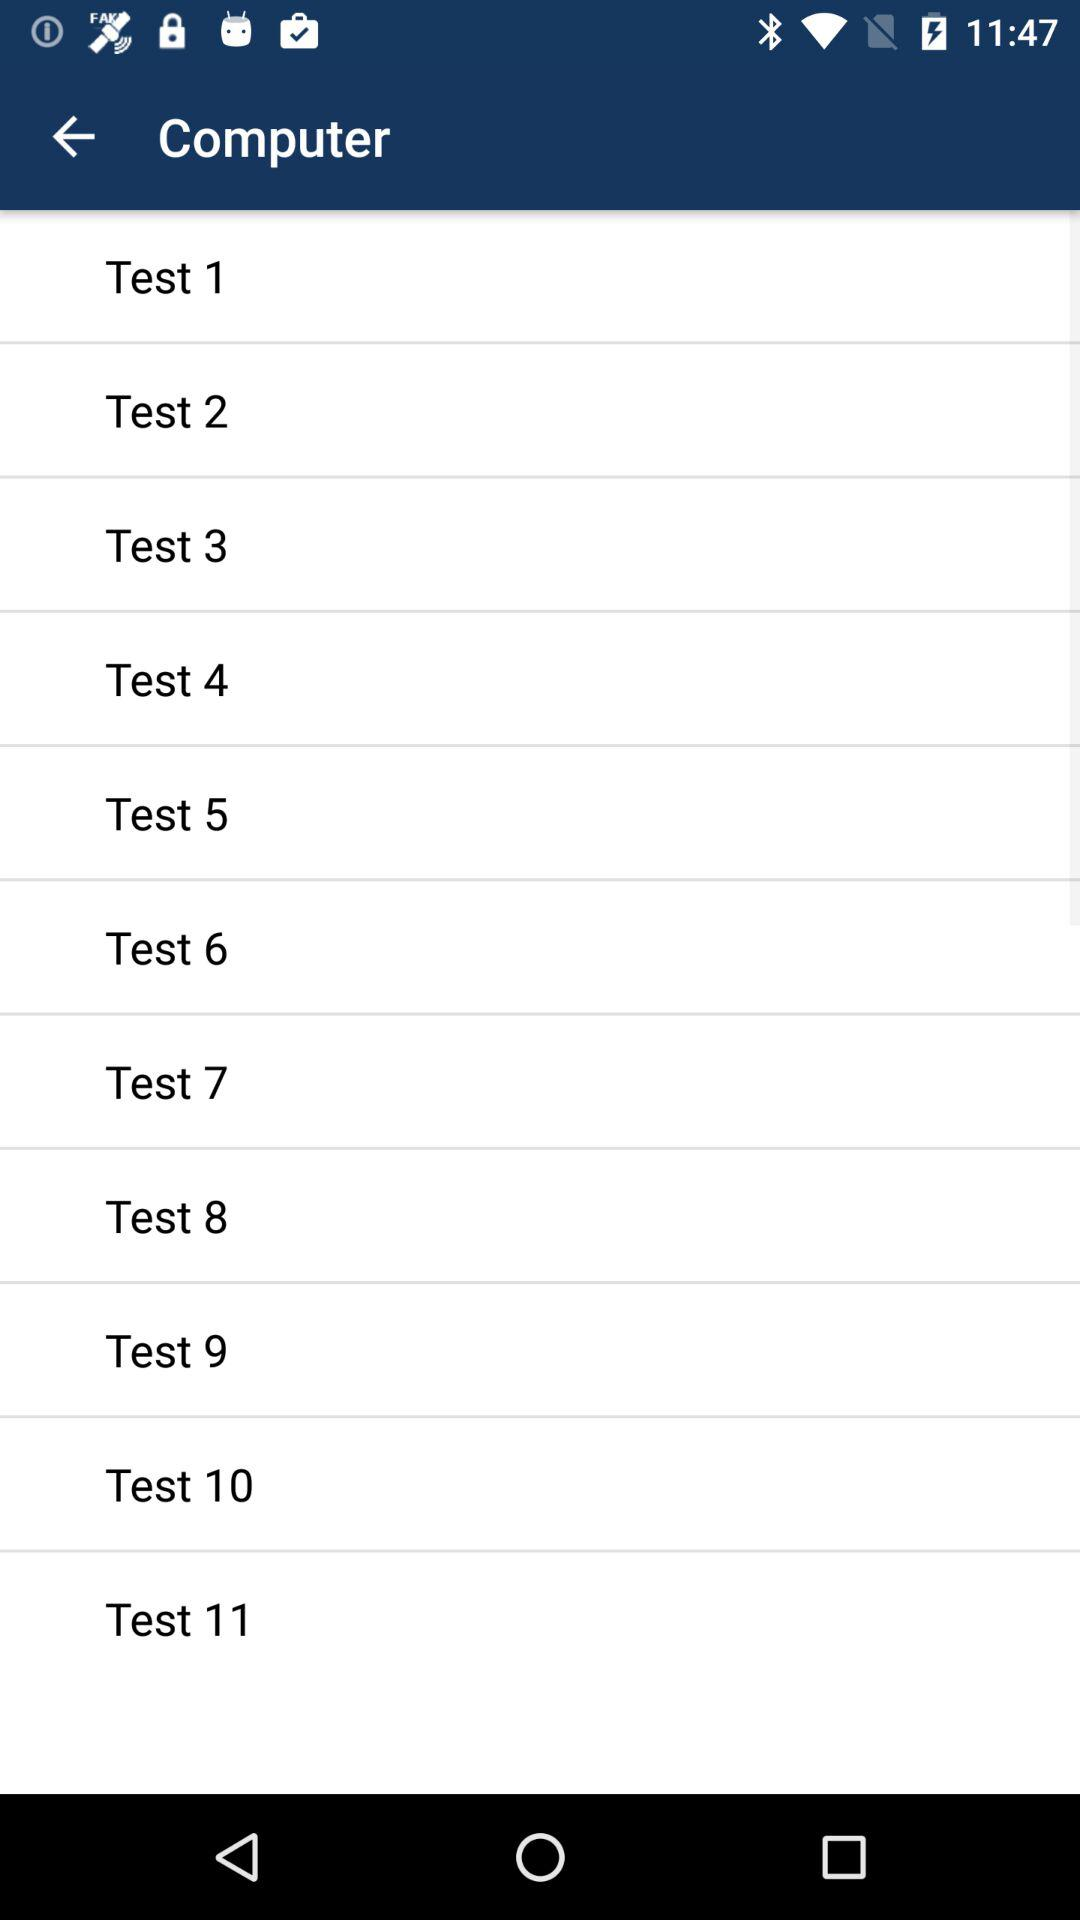How many test results are there?
Answer the question using a single word or phrase. 11 